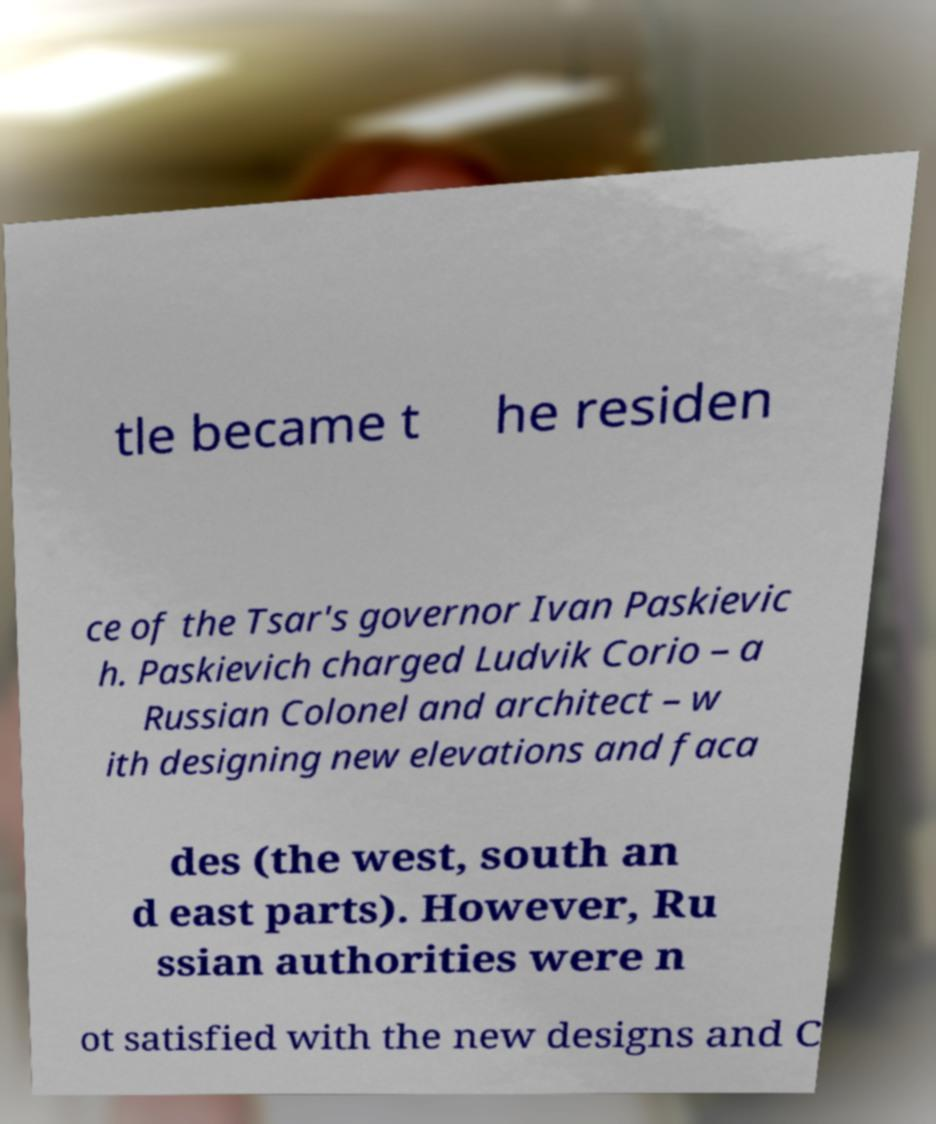I need the written content from this picture converted into text. Can you do that? tle became t he residen ce of the Tsar's governor Ivan Paskievic h. Paskievich charged Ludvik Corio – a Russian Colonel and architect – w ith designing new elevations and faca des (the west, south an d east parts). However, Ru ssian authorities were n ot satisfied with the new designs and C 